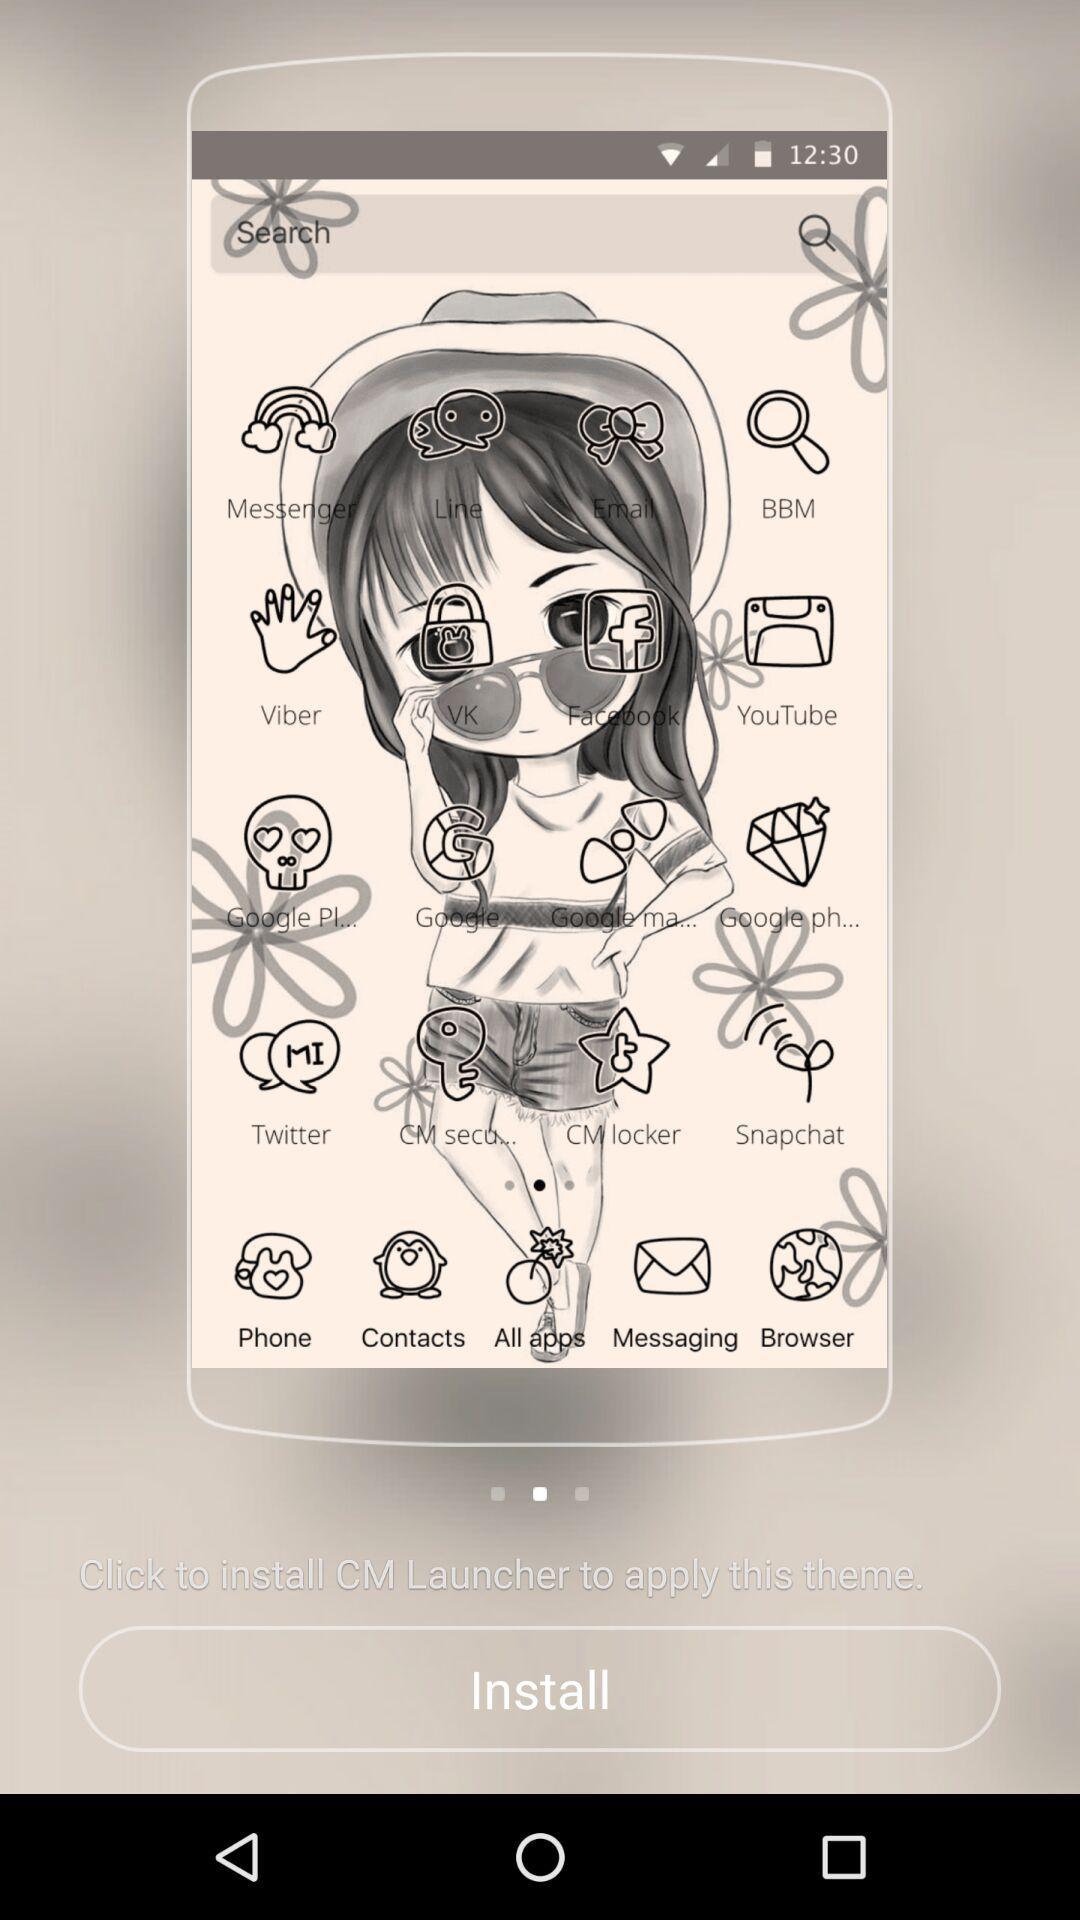How long does it take to install the application?
When the provided information is insufficient, respond with <no answer>. <no answer> 